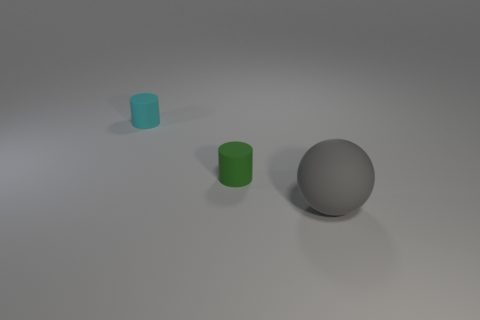Add 1 tiny matte objects. How many objects exist? 4 Subtract all cylinders. How many objects are left? 1 Subtract 0 brown cylinders. How many objects are left? 3 Subtract all large gray spheres. Subtract all cylinders. How many objects are left? 0 Add 2 green cylinders. How many green cylinders are left? 3 Add 2 small green rubber objects. How many small green rubber objects exist? 3 